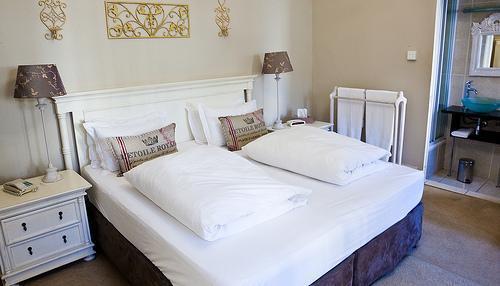How many lamps are there?
Give a very brief answer. 2. How many nightstands are in the picture?
Give a very brief answer. 2. How many phones are there?
Give a very brief answer. 1. 